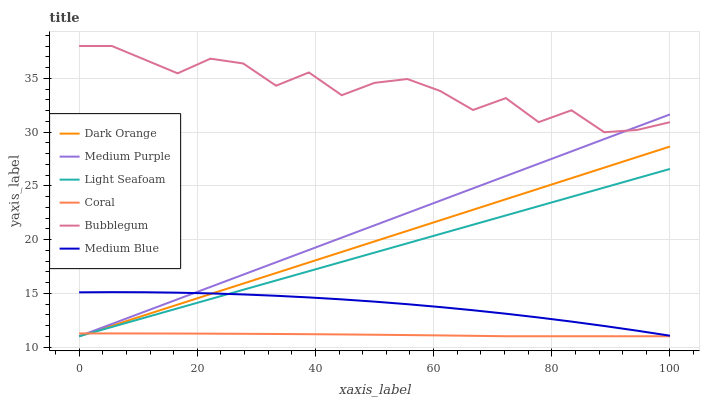Does Medium Blue have the minimum area under the curve?
Answer yes or no. No. Does Medium Blue have the maximum area under the curve?
Answer yes or no. No. Is Coral the smoothest?
Answer yes or no. No. Is Coral the roughest?
Answer yes or no. No. Does Medium Blue have the lowest value?
Answer yes or no. No. Does Medium Blue have the highest value?
Answer yes or no. No. Is Light Seafoam less than Bubblegum?
Answer yes or no. Yes. Is Medium Blue greater than Coral?
Answer yes or no. Yes. Does Light Seafoam intersect Bubblegum?
Answer yes or no. No. 